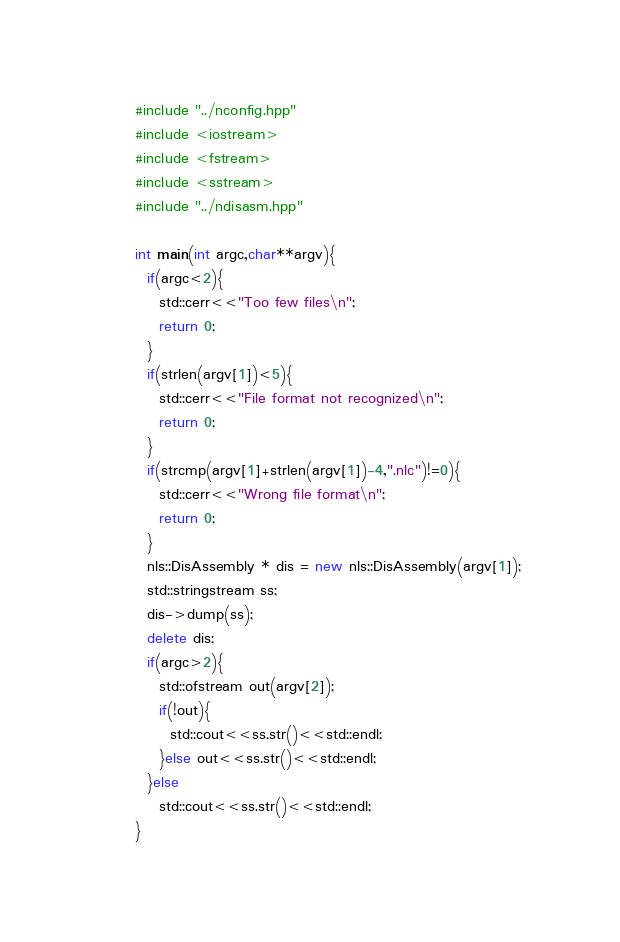Convert code to text. <code><loc_0><loc_0><loc_500><loc_500><_C++_>#include "../nconfig.hpp"
#include <iostream>
#include <fstream>
#include <sstream>
#include "../ndisasm.hpp"

int main(int argc,char**argv){
  if(argc<2){
    std::cerr<<"Too few files\n";
    return 0;
  }
  if(strlen(argv[1])<5){
    std::cerr<<"File format not recognized\n";
    return 0;
  }
  if(strcmp(argv[1]+strlen(argv[1])-4,".nlc")!=0){
    std::cerr<<"Wrong file format\n";
    return 0;
  }
  nls::DisAssembly * dis = new nls::DisAssembly(argv[1]);
  std::stringstream ss;
  dis->dump(ss);
  delete dis;
  if(argc>2){
    std::ofstream out(argv[2]);
    if(!out){
      std::cout<<ss.str()<<std::endl;
    }else out<<ss.str()<<std::endl;
  }else
    std::cout<<ss.str()<<std::endl;
}
</code> 